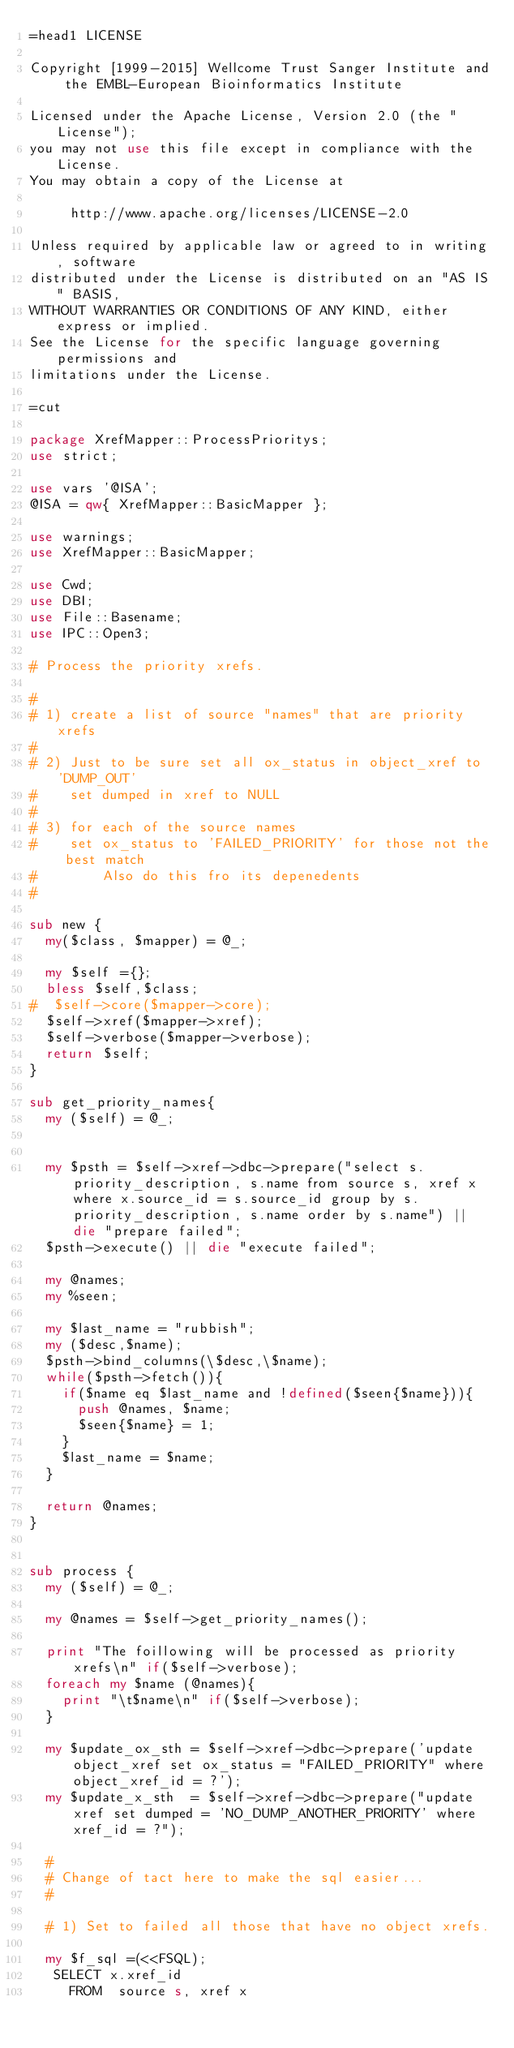<code> <loc_0><loc_0><loc_500><loc_500><_Perl_>=head1 LICENSE

Copyright [1999-2015] Wellcome Trust Sanger Institute and the EMBL-European Bioinformatics Institute

Licensed under the Apache License, Version 2.0 (the "License");
you may not use this file except in compliance with the License.
You may obtain a copy of the License at

     http://www.apache.org/licenses/LICENSE-2.0

Unless required by applicable law or agreed to in writing, software
distributed under the License is distributed on an "AS IS" BASIS,
WITHOUT WARRANTIES OR CONDITIONS OF ANY KIND, either express or implied.
See the License for the specific language governing permissions and
limitations under the License.

=cut

package XrefMapper::ProcessPrioritys;
use strict;

use vars '@ISA';
@ISA = qw{ XrefMapper::BasicMapper };

use warnings;
use XrefMapper::BasicMapper;

use Cwd;
use DBI;
use File::Basename;
use IPC::Open3;

# Process the priority xrefs.

#
# 1) create a list of source "names" that are priority xrefs
#
# 2) Just to be sure set all ox_status in object_xref to 'DUMP_OUT'
#    set dumped in xref to NULL
# 
# 3) for each of the source names 
#    set ox_status to 'FAILED_PRIORITY' for those not the best match
#        Also do this fro its depenedents
#

sub new {
  my($class, $mapper) = @_;

  my $self ={};
  bless $self,$class;
#  $self->core($mapper->core);
  $self->xref($mapper->xref);
  $self->verbose($mapper->verbose);
  return $self;
}

sub get_priority_names{
  my ($self) = @_;


  my $psth = $self->xref->dbc->prepare("select s.priority_description, s.name from source s, xref x where x.source_id = s.source_id group by s.priority_description, s.name order by s.name") || die "prepare failed";
  $psth->execute() || die "execute failed";

  my @names;
  my %seen;

  my $last_name = "rubbish";
  my ($desc,$name);
  $psth->bind_columns(\$desc,\$name);
  while($psth->fetch()){
    if($name eq $last_name and !defined($seen{$name})){
      push @names, $name;
      $seen{$name} = 1;
    }
    $last_name = $name;
  }

  return @names;
}


sub process {
  my ($self) = @_;

  my @names = $self->get_priority_names();

  print "The foillowing will be processed as priority xrefs\n" if($self->verbose);
  foreach my $name (@names){
    print "\t$name\n" if($self->verbose);
  }

  my $update_ox_sth = $self->xref->dbc->prepare('update object_xref set ox_status = "FAILED_PRIORITY" where object_xref_id = ?');
  my $update_x_sth  = $self->xref->dbc->prepare("update xref set dumped = 'NO_DUMP_ANOTHER_PRIORITY' where xref_id = ?");

  #
  # Change of tact here to make the sql easier...
  #

  # 1) Set to failed all those that have no object xrefs.

  my $f_sql =(<<FSQL);
   SELECT x.xref_id
     FROM  source s, xref x </code> 